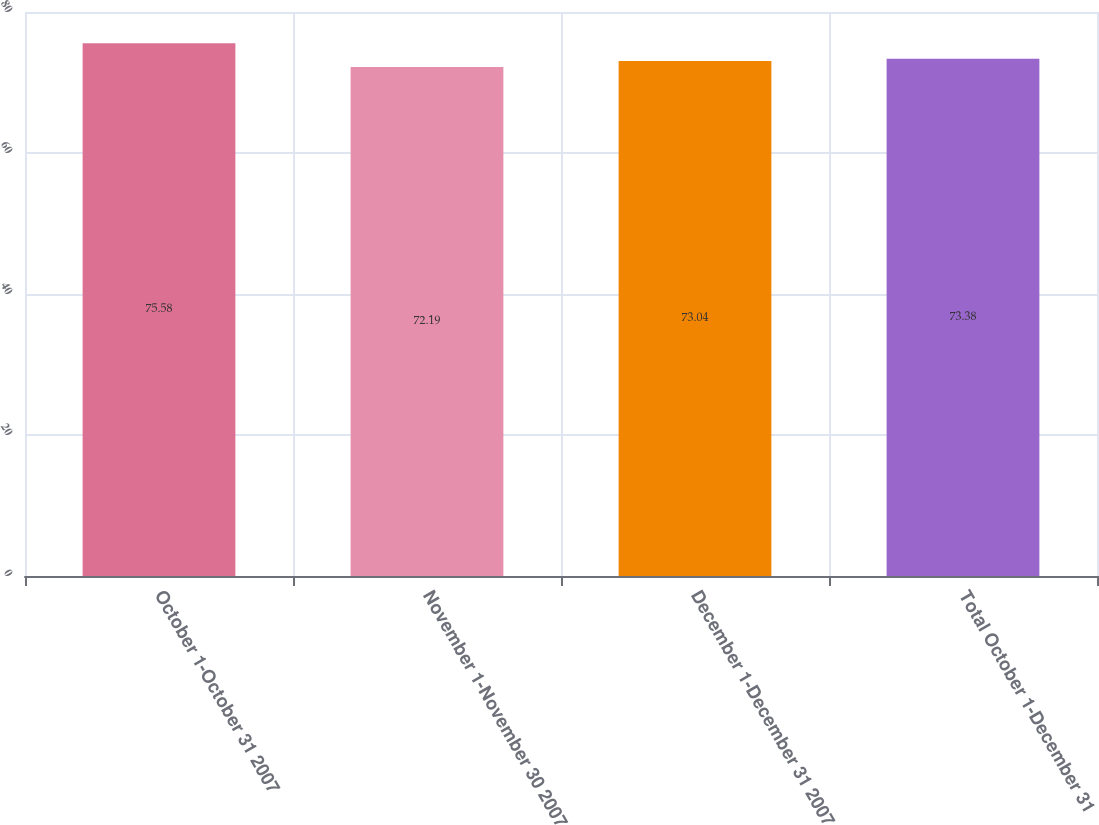Convert chart. <chart><loc_0><loc_0><loc_500><loc_500><bar_chart><fcel>October 1-October 31 2007<fcel>November 1-November 30 2007<fcel>December 1-December 31 2007<fcel>Total October 1-December 31<nl><fcel>75.58<fcel>72.19<fcel>73.04<fcel>73.38<nl></chart> 